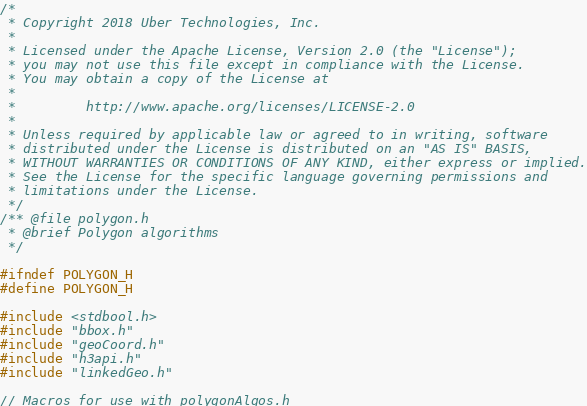Convert code to text. <code><loc_0><loc_0><loc_500><loc_500><_C_>/*
 * Copyright 2018 Uber Technologies, Inc.
 *
 * Licensed under the Apache License, Version 2.0 (the "License");
 * you may not use this file except in compliance with the License.
 * You may obtain a copy of the License at
 *
 *         http://www.apache.org/licenses/LICENSE-2.0
 *
 * Unless required by applicable law or agreed to in writing, software
 * distributed under the License is distributed on an "AS IS" BASIS,
 * WITHOUT WARRANTIES OR CONDITIONS OF ANY KIND, either express or implied.
 * See the License for the specific language governing permissions and
 * limitations under the License.
 */
/** @file polygon.h
 * @brief Polygon algorithms
 */

#ifndef POLYGON_H
#define POLYGON_H

#include <stdbool.h>
#include "bbox.h"
#include "geoCoord.h"
#include "h3api.h"
#include "linkedGeo.h"

// Macros for use with polygonAlgos.h</code> 